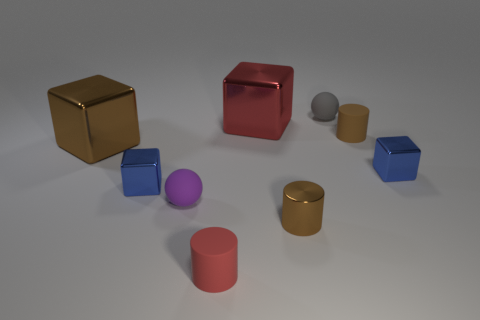Are there an equal number of brown metal cylinders that are on the right side of the gray ball and red cylinders behind the metallic cylinder?
Provide a succinct answer. Yes. The metallic cylinder is what color?
Give a very brief answer. Brown. How many objects are either small shiny blocks that are right of the tiny brown metallic cylinder or rubber things?
Your response must be concise. 5. There is a brown thing that is left of the metallic cylinder; does it have the same size as the blue thing that is left of the purple rubber object?
Give a very brief answer. No. Is there any other thing that is the same material as the large red cube?
Offer a very short reply. Yes. What number of objects are either blue blocks that are to the right of the tiny red rubber thing or small things that are on the left side of the red matte object?
Keep it short and to the point. 3. Is the material of the tiny purple thing the same as the large object that is behind the tiny brown rubber cylinder?
Give a very brief answer. No. What is the shape of the thing that is both in front of the large brown object and on the left side of the tiny purple rubber thing?
Ensure brevity in your answer.  Cube. What number of other objects are the same color as the metallic cylinder?
Keep it short and to the point. 2. The tiny red thing is what shape?
Provide a succinct answer. Cylinder. 